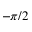<formula> <loc_0><loc_0><loc_500><loc_500>- \pi / 2</formula> 